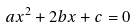<formula> <loc_0><loc_0><loc_500><loc_500>a x ^ { 2 } + 2 b x + c = 0</formula> 